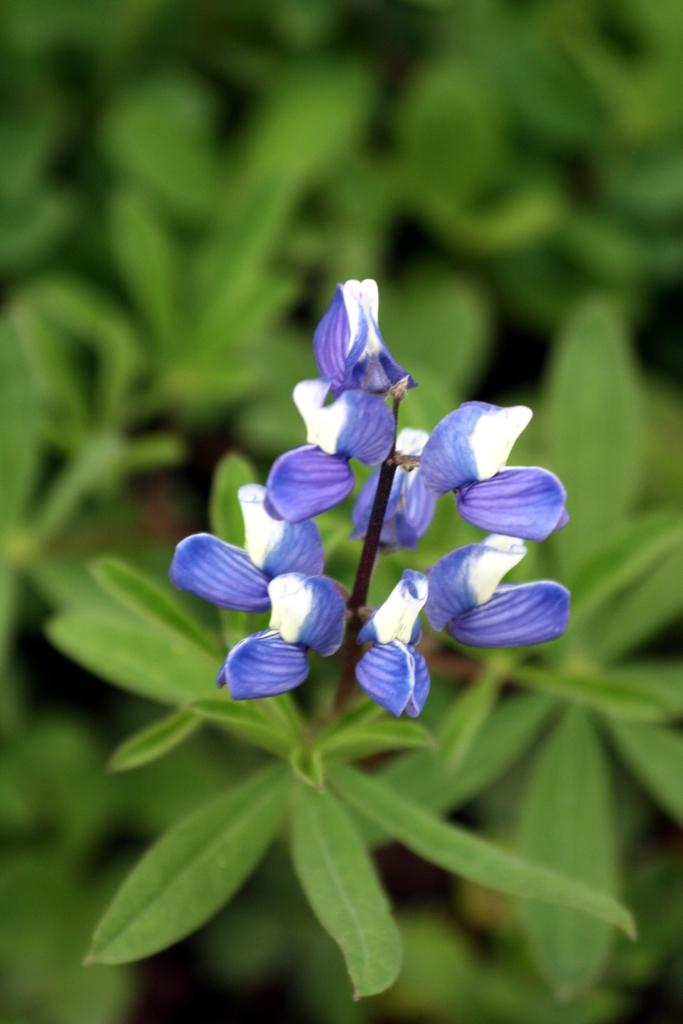What type of vegetation is in the foreground of the image? There are flowers in the foreground of the image. What can be seen in the background of the image? There are plants in the background of the image. What is the belief of the leg in the image? There is no leg present in the image, so it is not possible to determine any beliefs. 